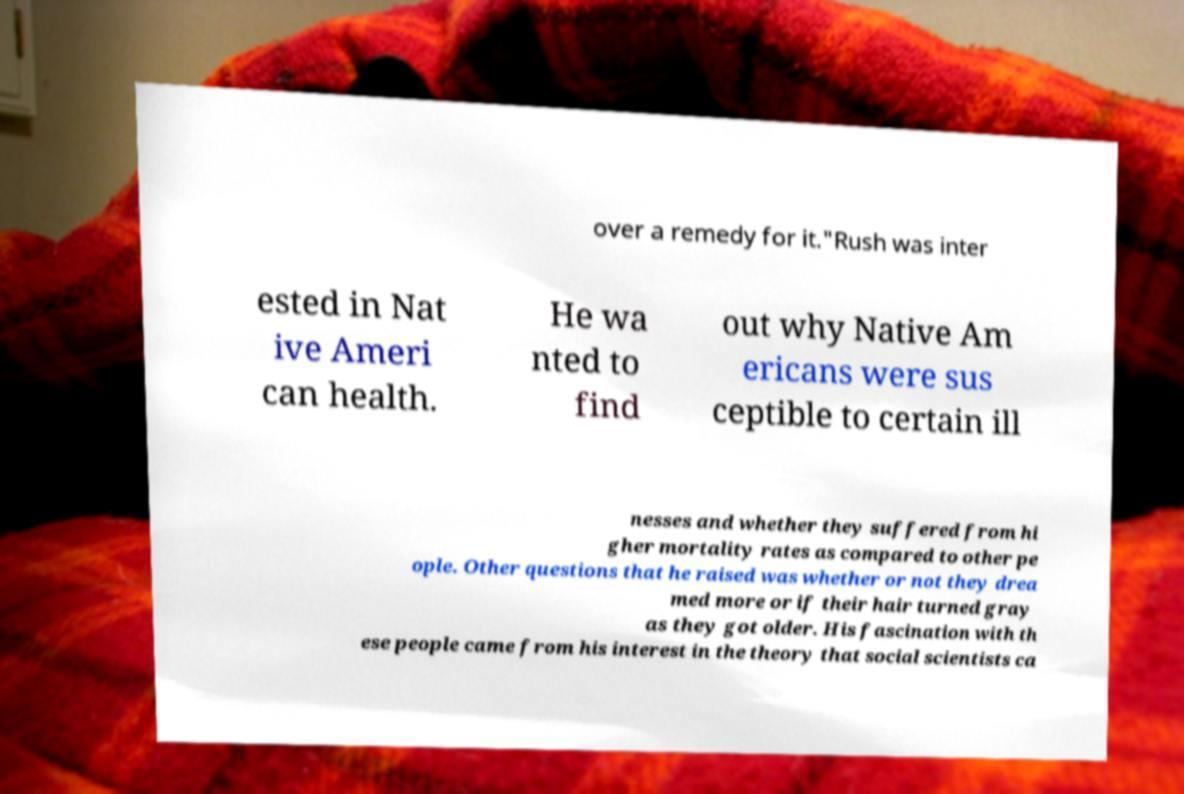What messages or text are displayed in this image? I need them in a readable, typed format. over a remedy for it."Rush was inter ested in Nat ive Ameri can health. He wa nted to find out why Native Am ericans were sus ceptible to certain ill nesses and whether they suffered from hi gher mortality rates as compared to other pe ople. Other questions that he raised was whether or not they drea med more or if their hair turned gray as they got older. His fascination with th ese people came from his interest in the theory that social scientists ca 